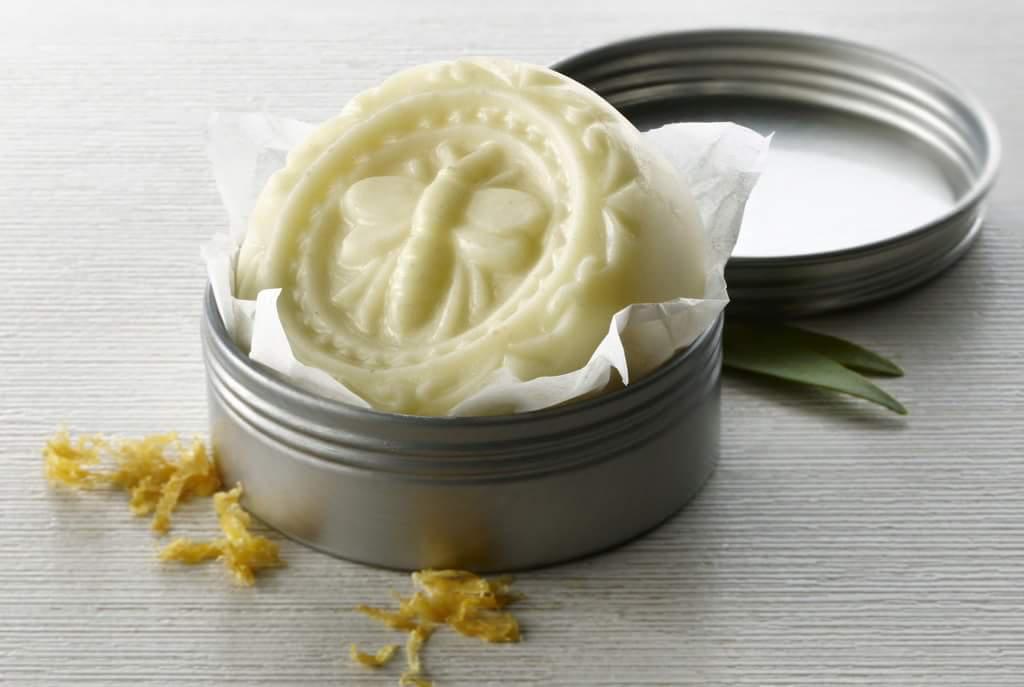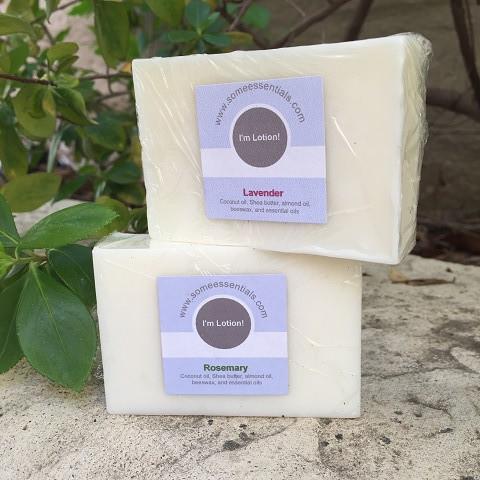The first image is the image on the left, the second image is the image on the right. Evaluate the accuracy of this statement regarding the images: "A circular bar of soap has a bee imprinted on it.". Is it true? Answer yes or no. Yes. 